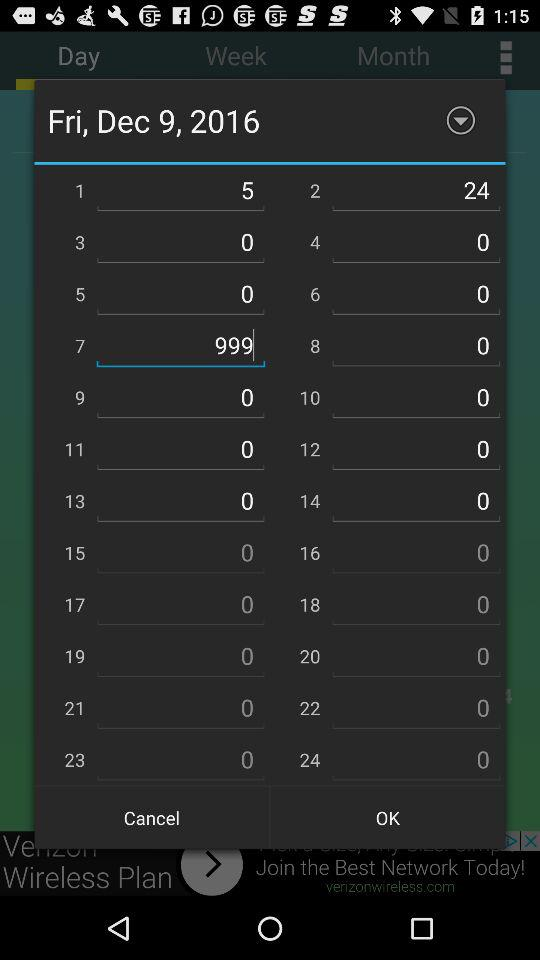What is the number that was entered in the 2nd S.no.? The number entered is 24. 